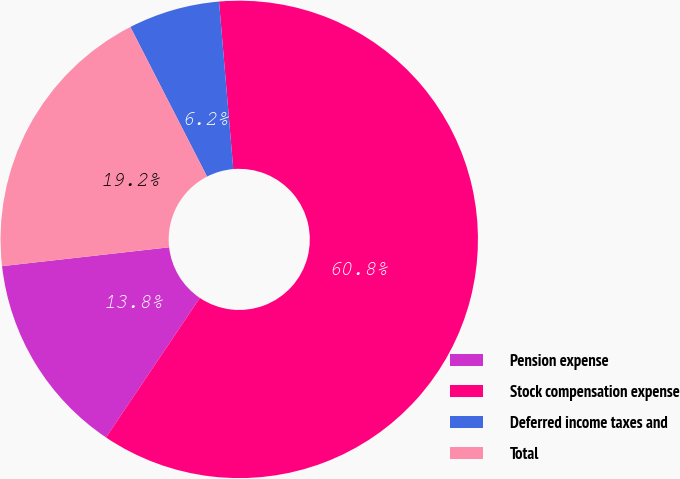<chart> <loc_0><loc_0><loc_500><loc_500><pie_chart><fcel>Pension expense<fcel>Stock compensation expense<fcel>Deferred income taxes and<fcel>Total<nl><fcel>13.79%<fcel>60.78%<fcel>6.19%<fcel>19.25%<nl></chart> 